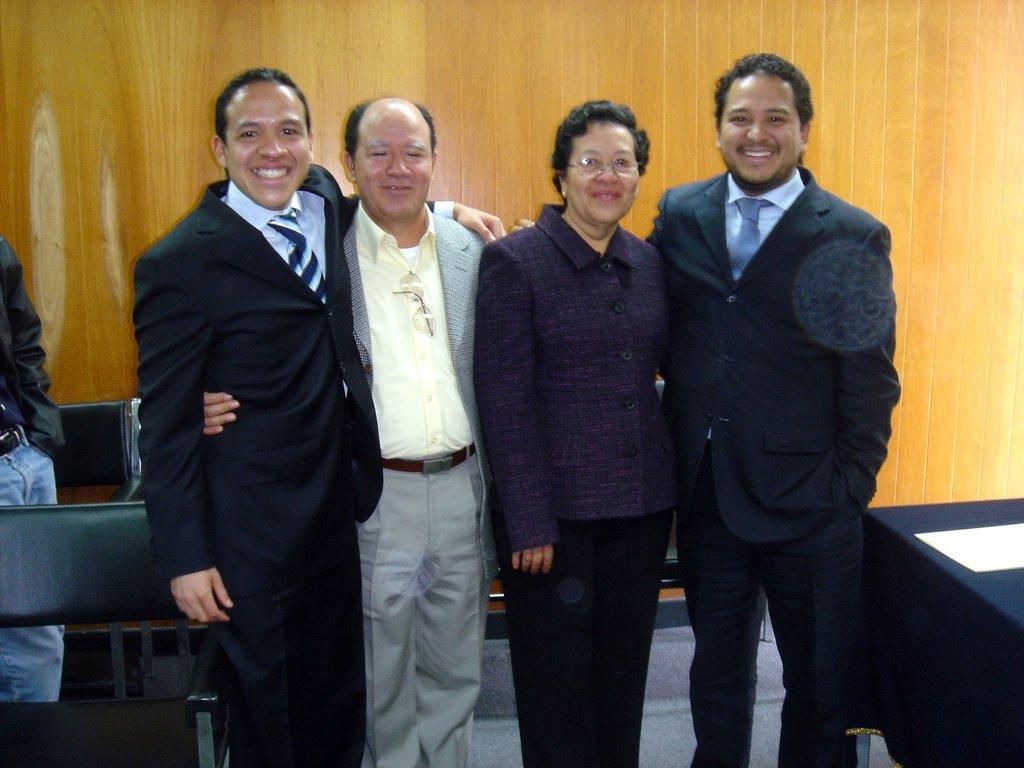Could you give a brief overview of what you see in this image? In the foreground of this picture, there are three men and a woman standing and smiling. In the background, there is a table, benches and a man standing and a wooden wall. 